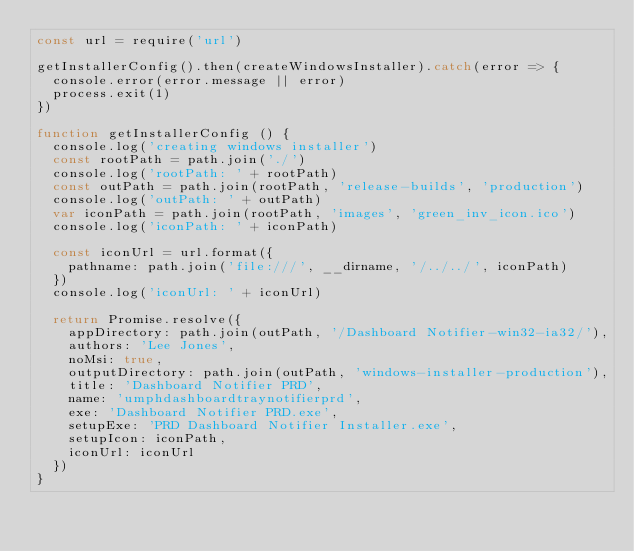<code> <loc_0><loc_0><loc_500><loc_500><_JavaScript_>const url = require('url')

getInstallerConfig().then(createWindowsInstaller).catch(error => {
  console.error(error.message || error)
  process.exit(1)
})

function getInstallerConfig () {
  console.log('creating windows installer')
  const rootPath = path.join('./')
  console.log('rootPath: ' + rootPath)
  const outPath = path.join(rootPath, 'release-builds', 'production')
  console.log('outPath: ' + outPath)
  var iconPath = path.join(rootPath, 'images', 'green_inv_icon.ico')
  console.log('iconPath: ' + iconPath)

  const iconUrl = url.format({
    pathname: path.join('file:///', __dirname, '/../../', iconPath)
  })
  console.log('iconUrl: ' + iconUrl)

  return Promise.resolve({
    appDirectory: path.join(outPath, '/Dashboard Notifier-win32-ia32/'),
    authors: 'Lee Jones',
    noMsi: true,
    outputDirectory: path.join(outPath, 'windows-installer-production'),
    title: 'Dashboard Notifier PRD',
    name: 'umphdashboardtraynotifierprd',
    exe: 'Dashboard Notifier PRD.exe',
    setupExe: 'PRD Dashboard Notifier Installer.exe',
    setupIcon: iconPath,
    iconUrl: iconUrl
  })
}
</code> 